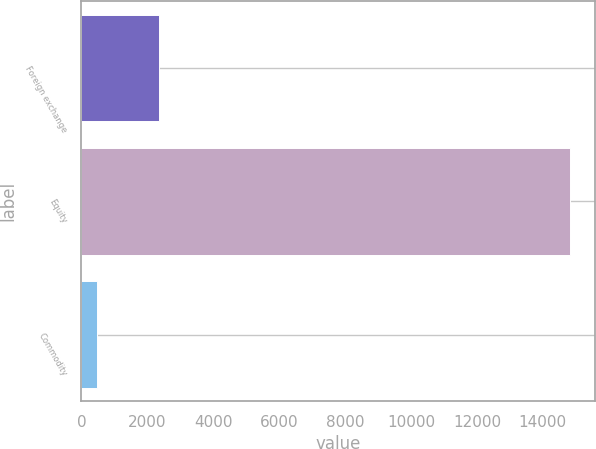<chart> <loc_0><loc_0><loc_500><loc_500><bar_chart><fcel>Foreign exchange<fcel>Equity<fcel>Commodity<nl><fcel>2365<fcel>14831<fcel>488<nl></chart> 